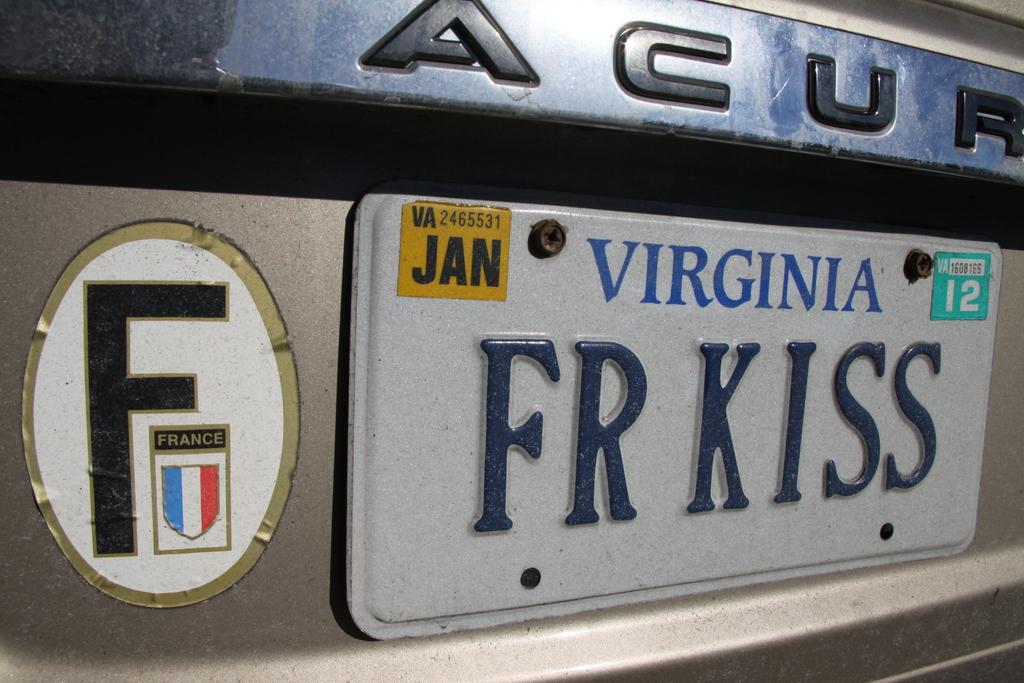What month is on the license plate?
Your answer should be compact. January. 